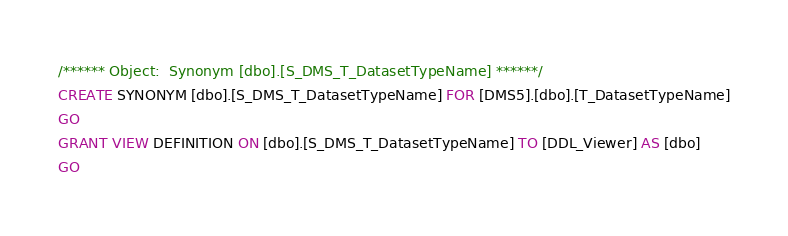<code> <loc_0><loc_0><loc_500><loc_500><_SQL_>/****** Object:  Synonym [dbo].[S_DMS_T_DatasetTypeName] ******/
CREATE SYNONYM [dbo].[S_DMS_T_DatasetTypeName] FOR [DMS5].[dbo].[T_DatasetTypeName]
GO
GRANT VIEW DEFINITION ON [dbo].[S_DMS_T_DatasetTypeName] TO [DDL_Viewer] AS [dbo]
GO
</code> 